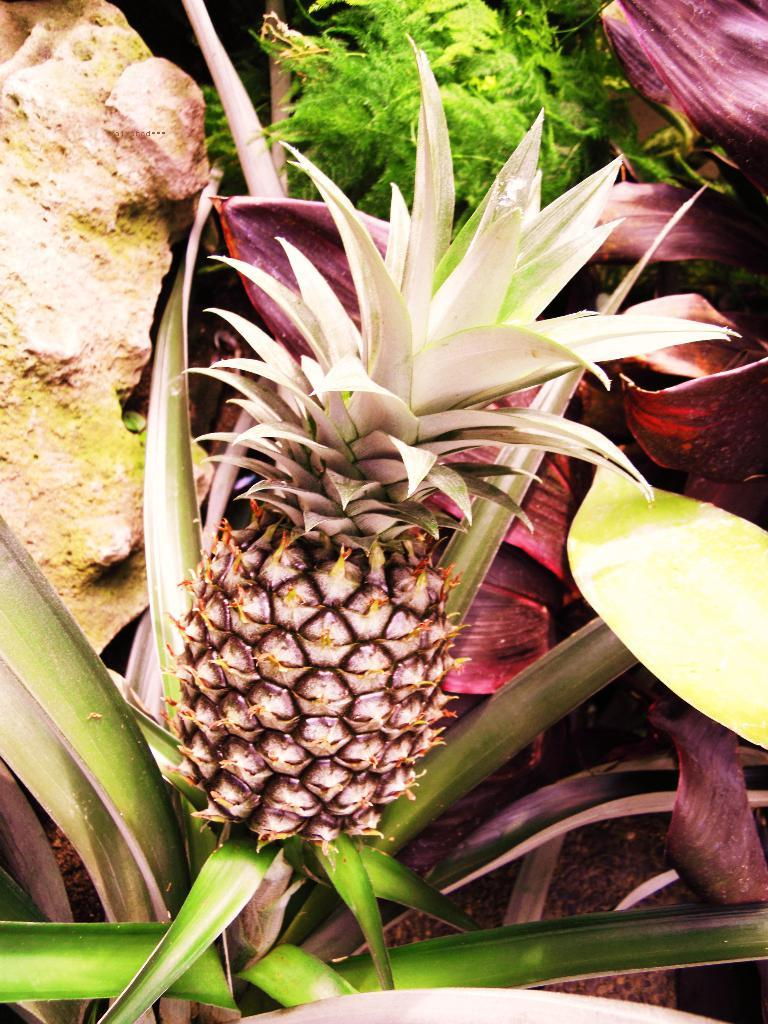What type of fruit can be seen in the image? There is a pineapple in the image. What other living organism is present in the image? There is a plant in the image. What part of the plant is visible in the image? Leaves are present in the image. What non-living object can be seen in the image? There is a rock in the image. What type of soap is being used to clean the pineapple in the image? There is no soap or cleaning activity present in the image; it only features a pineapple, a plant, leaves, and a rock. 